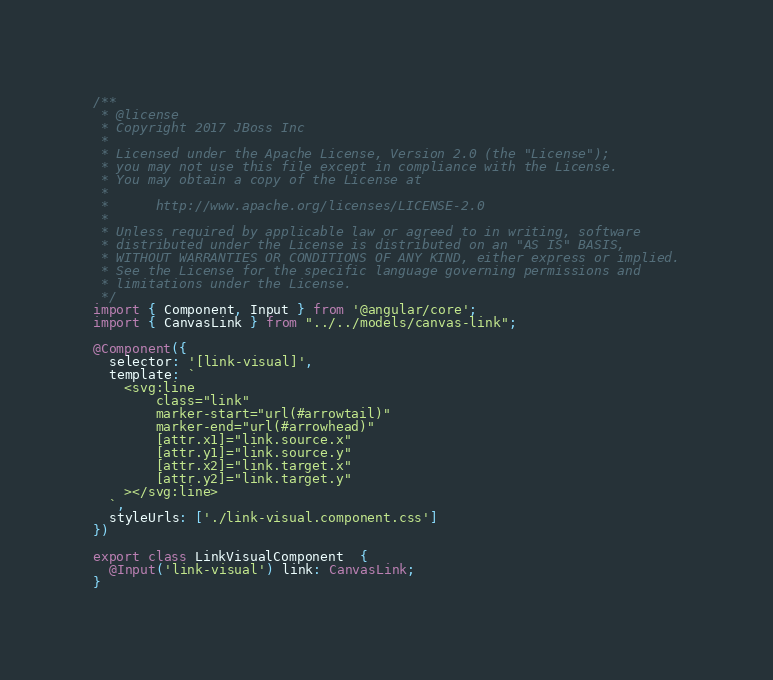<code> <loc_0><loc_0><loc_500><loc_500><_TypeScript_>/**
 * @license
 * Copyright 2017 JBoss Inc
 *
 * Licensed under the Apache License, Version 2.0 (the "License");
 * you may not use this file except in compliance with the License.
 * You may obtain a copy of the License at
 *
 *      http://www.apache.org/licenses/LICENSE-2.0
 *
 * Unless required by applicable law or agreed to in writing, software
 * distributed under the License is distributed on an "AS IS" BASIS,
 * WITHOUT WARRANTIES OR CONDITIONS OF ANY KIND, either express or implied.
 * See the License for the specific language governing permissions and
 * limitations under the License.
 */
import { Component, Input } from '@angular/core';
import { CanvasLink } from "../../models/canvas-link";

@Component({
  selector: '[link-visual]',
  template: `
    <svg:line
        class="link"
        marker-start="url(#arrowtail)"
        marker-end="url(#arrowhead)"
        [attr.x1]="link.source.x"
        [attr.y1]="link.source.y"
        [attr.x2]="link.target.x"
        [attr.y2]="link.target.y"
    ></svg:line>
  `,
  styleUrls: ['./link-visual.component.css']
})

export class LinkVisualComponent  {
  @Input('link-visual') link: CanvasLink;
}
</code> 